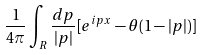Convert formula to latex. <formula><loc_0><loc_0><loc_500><loc_500>\frac { 1 } { 4 \pi } \int _ { R } \frac { d p } { | p | } [ e ^ { i p x } - \theta ( 1 - | p | ) ]</formula> 